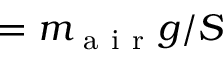Convert formula to latex. <formula><loc_0><loc_0><loc_500><loc_500>= m _ { a i r } g / S</formula> 